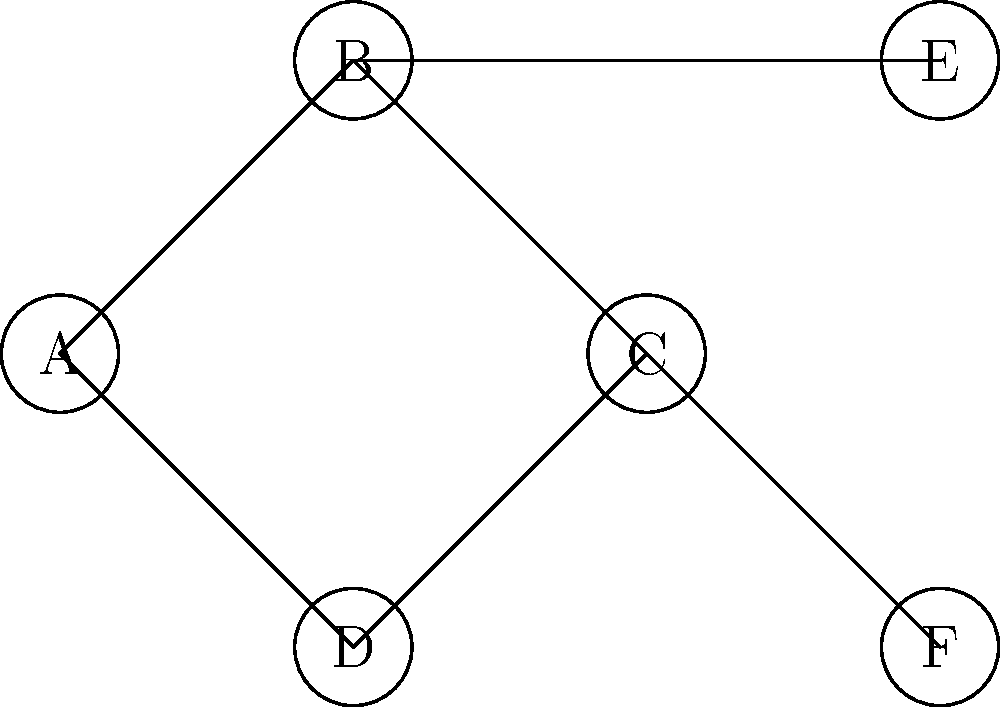In the network diagram above, tea ceremony enthusiasts are represented by nodes, and connections between them are represented by edges. Which node would be the most strategic to designate as a central hub for disseminating information about traditional tea ceremony products, considering both reach and efficiency? To determine the most strategic node for a central hub, we need to analyze the network structure and consider the following factors:

1. Degree centrality: The number of direct connections a node has.
2. Betweenness centrality: How often a node acts as a bridge between other nodes.
3. Closeness centrality: The average distance from a node to all other nodes.

Let's examine each node:

A: Connected to B, C, and D (degree = 3)
B: Connected to A, C, and E (degree = 3)
C: Connected to A, B, D, and F (degree = 4)
D: Connected to A and C (degree = 2)
E: Connected to B (degree = 1)
F: Connected to C (degree = 1)

Node C has the highest degree centrality (4 connections), making it the most connected node in the network.

In terms of betweenness centrality, node C is on the shortest path between multiple pairs of nodes (e.g., E-F, E-D, B-F), giving it high betweenness centrality.

For closeness centrality, node C has the shortest average distance to all other nodes in the network.

Given these factors, node C is the most strategic choice for a central hub because:
1. It has the most direct connections (highest degree centrality).
2. It serves as a bridge between many nodes (high betweenness centrality).
3. It has the closest average distance to all other nodes (high closeness centrality).

This position would allow for efficient dissemination of information about traditional tea ceremony products to the entire network.
Answer: Node C 